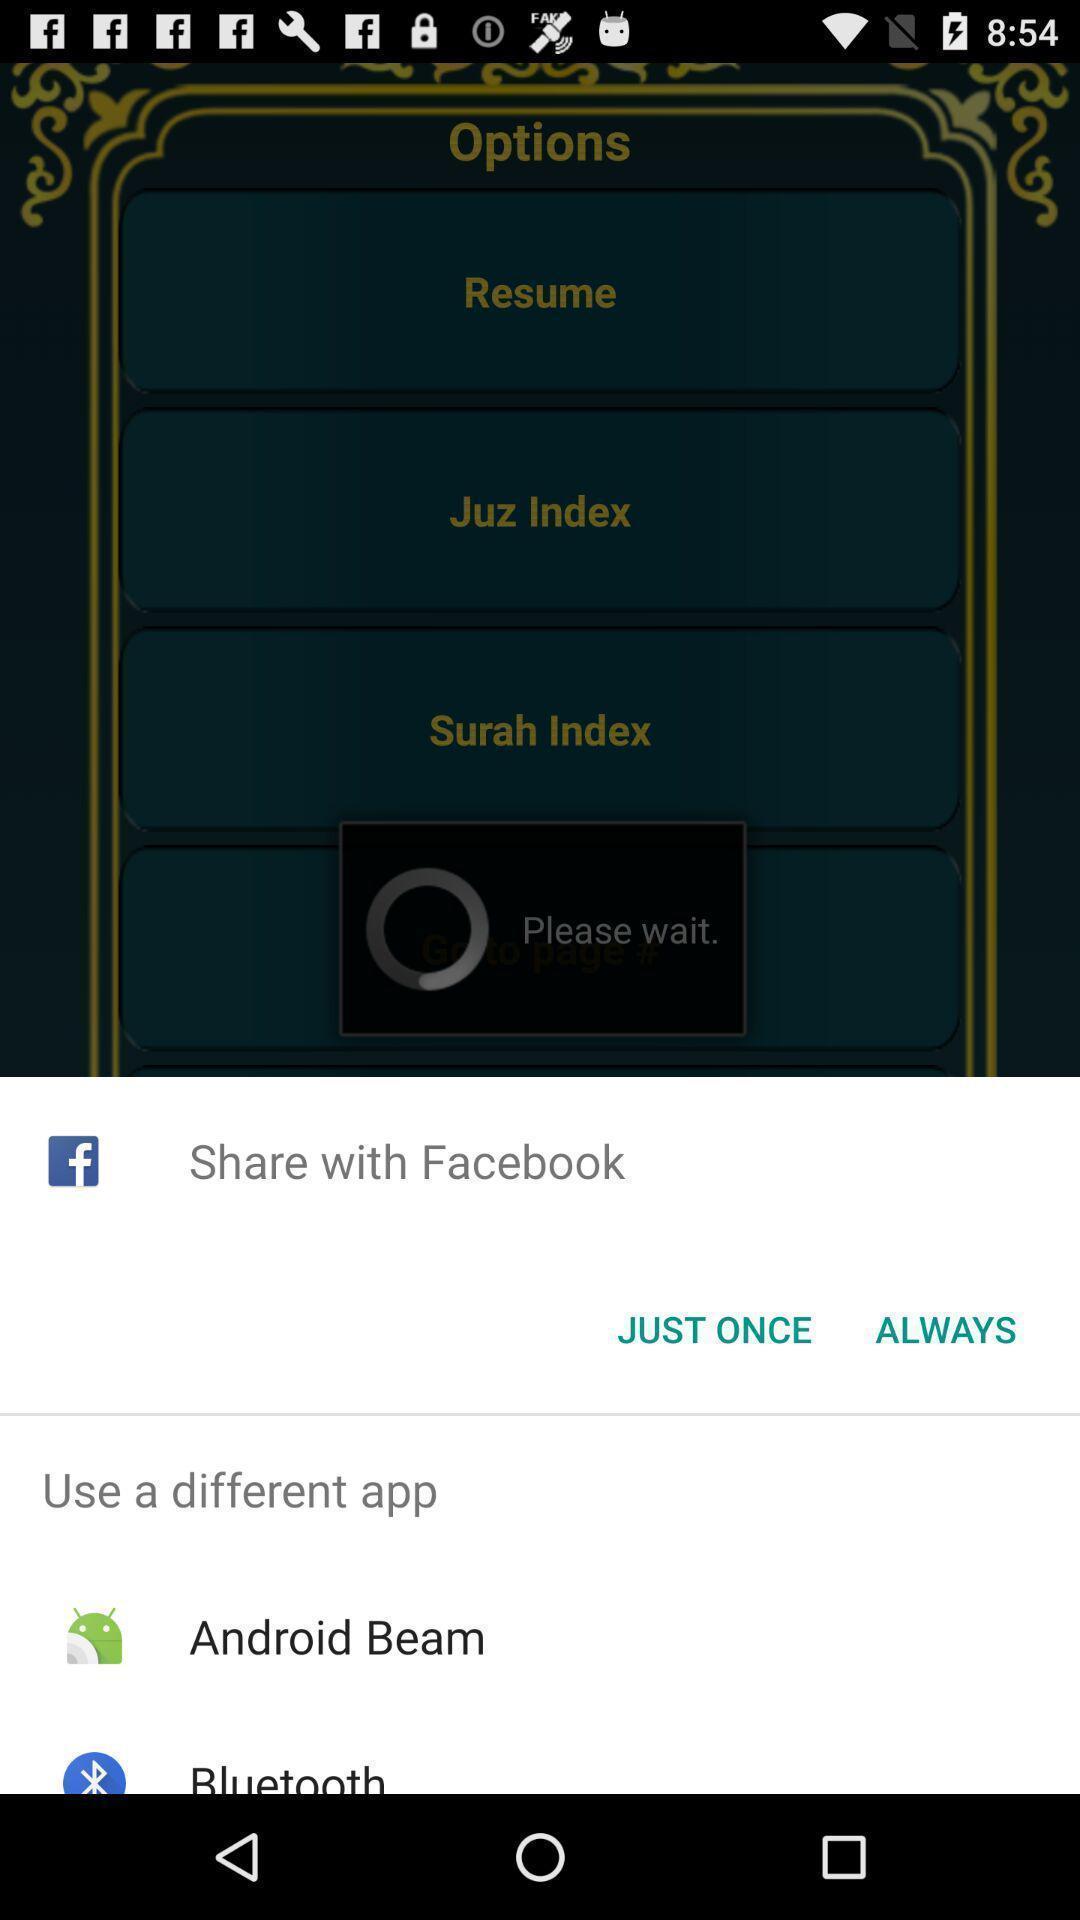Tell me what you see in this picture. Popup showing few sharing options with icons in holy-book app. 